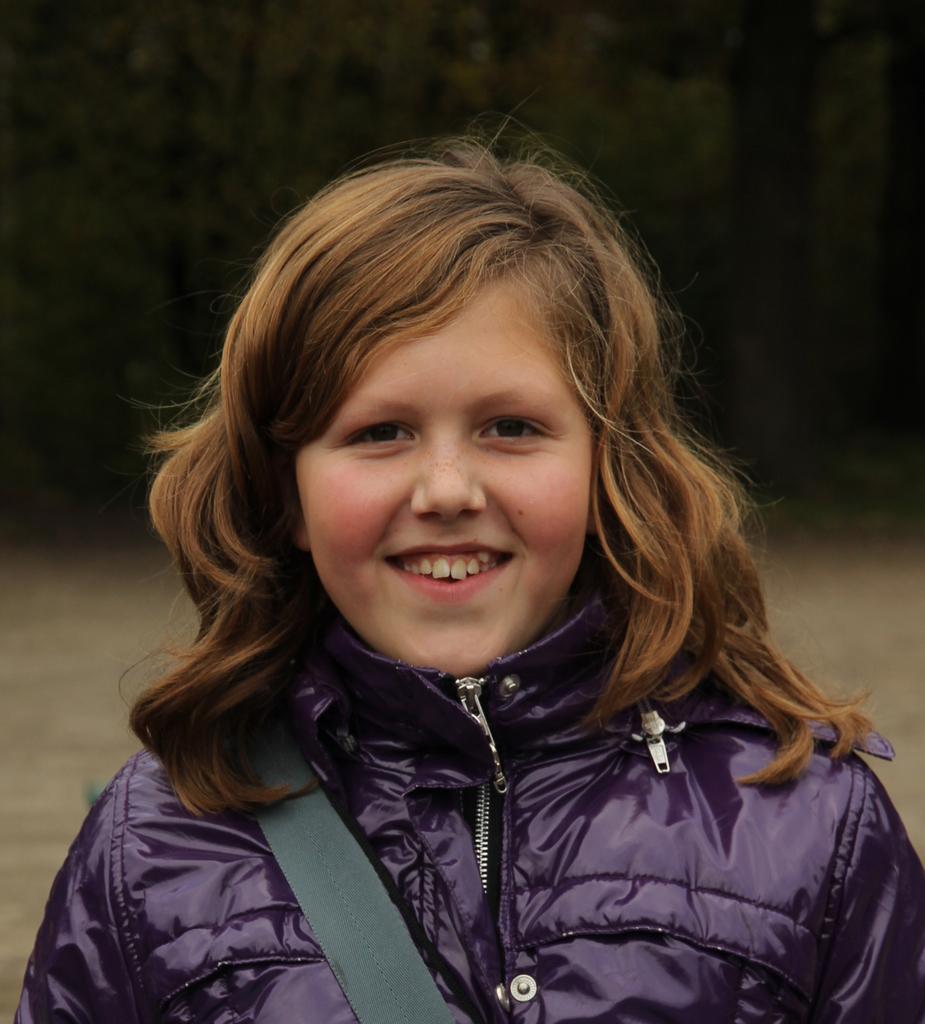Could you give a brief overview of what you see in this image? In the image we can see a girl wearing a jacket and the girl is smiling, this is a belt and the background is blurred. 